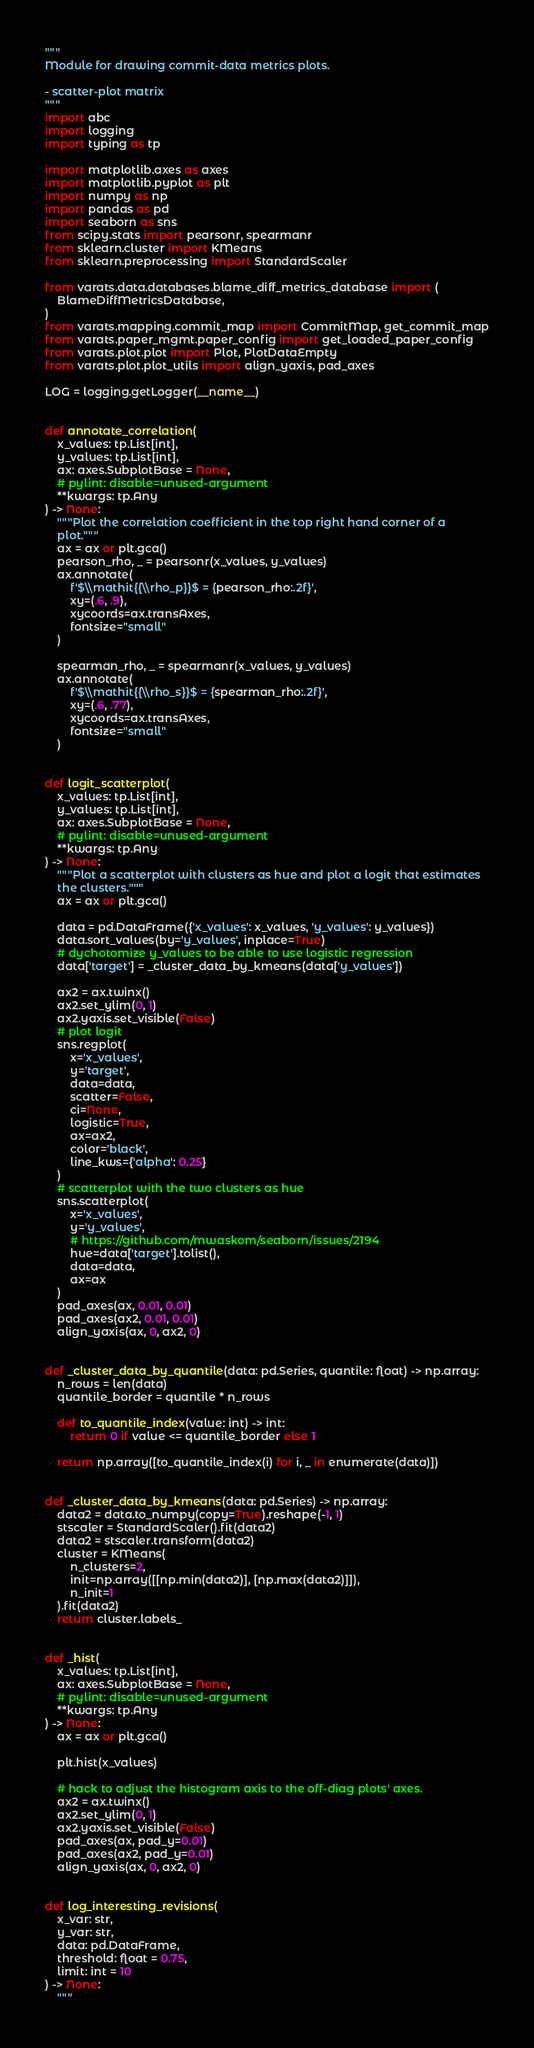Convert code to text. <code><loc_0><loc_0><loc_500><loc_500><_Python_>"""
Module for drawing commit-data metrics plots.

- scatter-plot matrix
"""
import abc
import logging
import typing as tp

import matplotlib.axes as axes
import matplotlib.pyplot as plt
import numpy as np
import pandas as pd
import seaborn as sns
from scipy.stats import pearsonr, spearmanr
from sklearn.cluster import KMeans
from sklearn.preprocessing import StandardScaler

from varats.data.databases.blame_diff_metrics_database import (
    BlameDiffMetricsDatabase,
)
from varats.mapping.commit_map import CommitMap, get_commit_map
from varats.paper_mgmt.paper_config import get_loaded_paper_config
from varats.plot.plot import Plot, PlotDataEmpty
from varats.plot.plot_utils import align_yaxis, pad_axes

LOG = logging.getLogger(__name__)


def annotate_correlation(
    x_values: tp.List[int],
    y_values: tp.List[int],
    ax: axes.SubplotBase = None,
    # pylint: disable=unused-argument
    **kwargs: tp.Any
) -> None:
    """Plot the correlation coefficient in the top right hand corner of a
    plot."""
    ax = ax or plt.gca()
    pearson_rho, _ = pearsonr(x_values, y_values)
    ax.annotate(
        f'$\\mathit{{\\rho_p}}$ = {pearson_rho:.2f}',
        xy=(.6, .9),
        xycoords=ax.transAxes,
        fontsize="small"
    )

    spearman_rho, _ = spearmanr(x_values, y_values)
    ax.annotate(
        f'$\\mathit{{\\rho_s}}$ = {spearman_rho:.2f}',
        xy=(.6, .77),
        xycoords=ax.transAxes,
        fontsize="small"
    )


def logit_scatterplot(
    x_values: tp.List[int],
    y_values: tp.List[int],
    ax: axes.SubplotBase = None,
    # pylint: disable=unused-argument
    **kwargs: tp.Any
) -> None:
    """Plot a scatterplot with clusters as hue and plot a logit that estimates
    the clusters."""
    ax = ax or plt.gca()

    data = pd.DataFrame({'x_values': x_values, 'y_values': y_values})
    data.sort_values(by='y_values', inplace=True)
    # dychotomize y_values to be able to use logistic regression
    data['target'] = _cluster_data_by_kmeans(data['y_values'])

    ax2 = ax.twinx()
    ax2.set_ylim(0, 1)
    ax2.yaxis.set_visible(False)
    # plot logit
    sns.regplot(
        x='x_values',
        y='target',
        data=data,
        scatter=False,
        ci=None,
        logistic=True,
        ax=ax2,
        color='black',
        line_kws={'alpha': 0.25}
    )
    # scatterplot with the two clusters as hue
    sns.scatterplot(
        x='x_values',
        y='y_values',
        # https://github.com/mwaskom/seaborn/issues/2194
        hue=data['target'].tolist(),
        data=data,
        ax=ax
    )
    pad_axes(ax, 0.01, 0.01)
    pad_axes(ax2, 0.01, 0.01)
    align_yaxis(ax, 0, ax2, 0)


def _cluster_data_by_quantile(data: pd.Series, quantile: float) -> np.array:
    n_rows = len(data)
    quantile_border = quantile * n_rows

    def to_quantile_index(value: int) -> int:
        return 0 if value <= quantile_border else 1

    return np.array([to_quantile_index(i) for i, _ in enumerate(data)])


def _cluster_data_by_kmeans(data: pd.Series) -> np.array:
    data2 = data.to_numpy(copy=True).reshape(-1, 1)
    stscaler = StandardScaler().fit(data2)
    data2 = stscaler.transform(data2)
    cluster = KMeans(
        n_clusters=2,
        init=np.array([[np.min(data2)], [np.max(data2)]]),
        n_init=1
    ).fit(data2)
    return cluster.labels_


def _hist(
    x_values: tp.List[int],
    ax: axes.SubplotBase = None,
    # pylint: disable=unused-argument
    **kwargs: tp.Any
) -> None:
    ax = ax or plt.gca()

    plt.hist(x_values)

    # hack to adjust the histogram axis to the off-diag plots' axes.
    ax2 = ax.twinx()
    ax2.set_ylim(0, 1)
    ax2.yaxis.set_visible(False)
    pad_axes(ax, pad_y=0.01)
    pad_axes(ax2, pad_y=0.01)
    align_yaxis(ax, 0, ax2, 0)


def log_interesting_revisions(
    x_var: str,
    y_var: str,
    data: pd.DataFrame,
    threshold: float = 0.75,
    limit: int = 10
) -> None:
    """</code> 